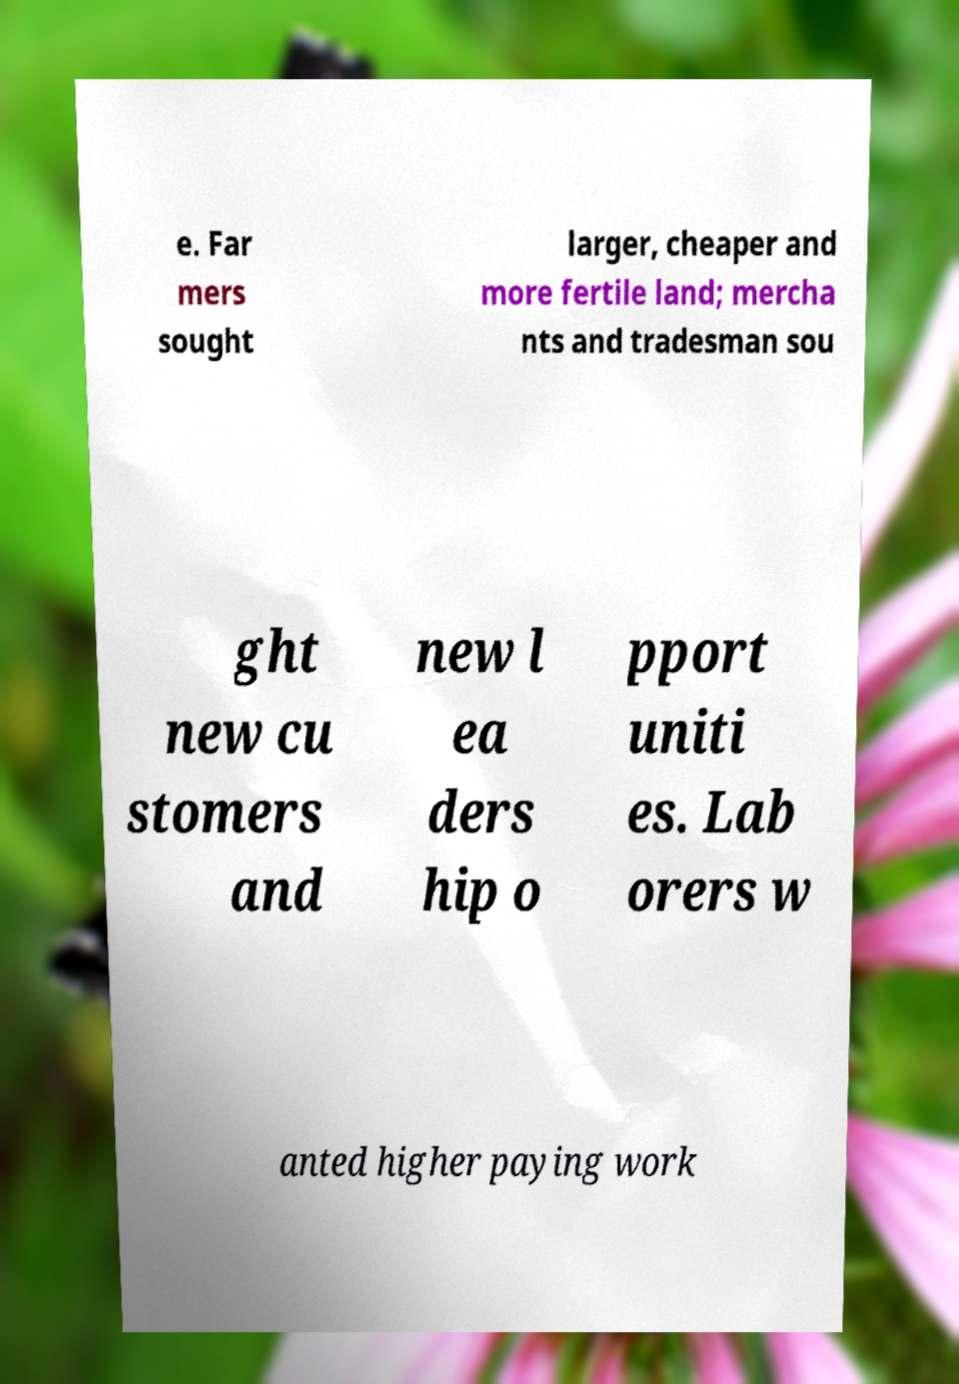There's text embedded in this image that I need extracted. Can you transcribe it verbatim? e. Far mers sought larger, cheaper and more fertile land; mercha nts and tradesman sou ght new cu stomers and new l ea ders hip o pport uniti es. Lab orers w anted higher paying work 